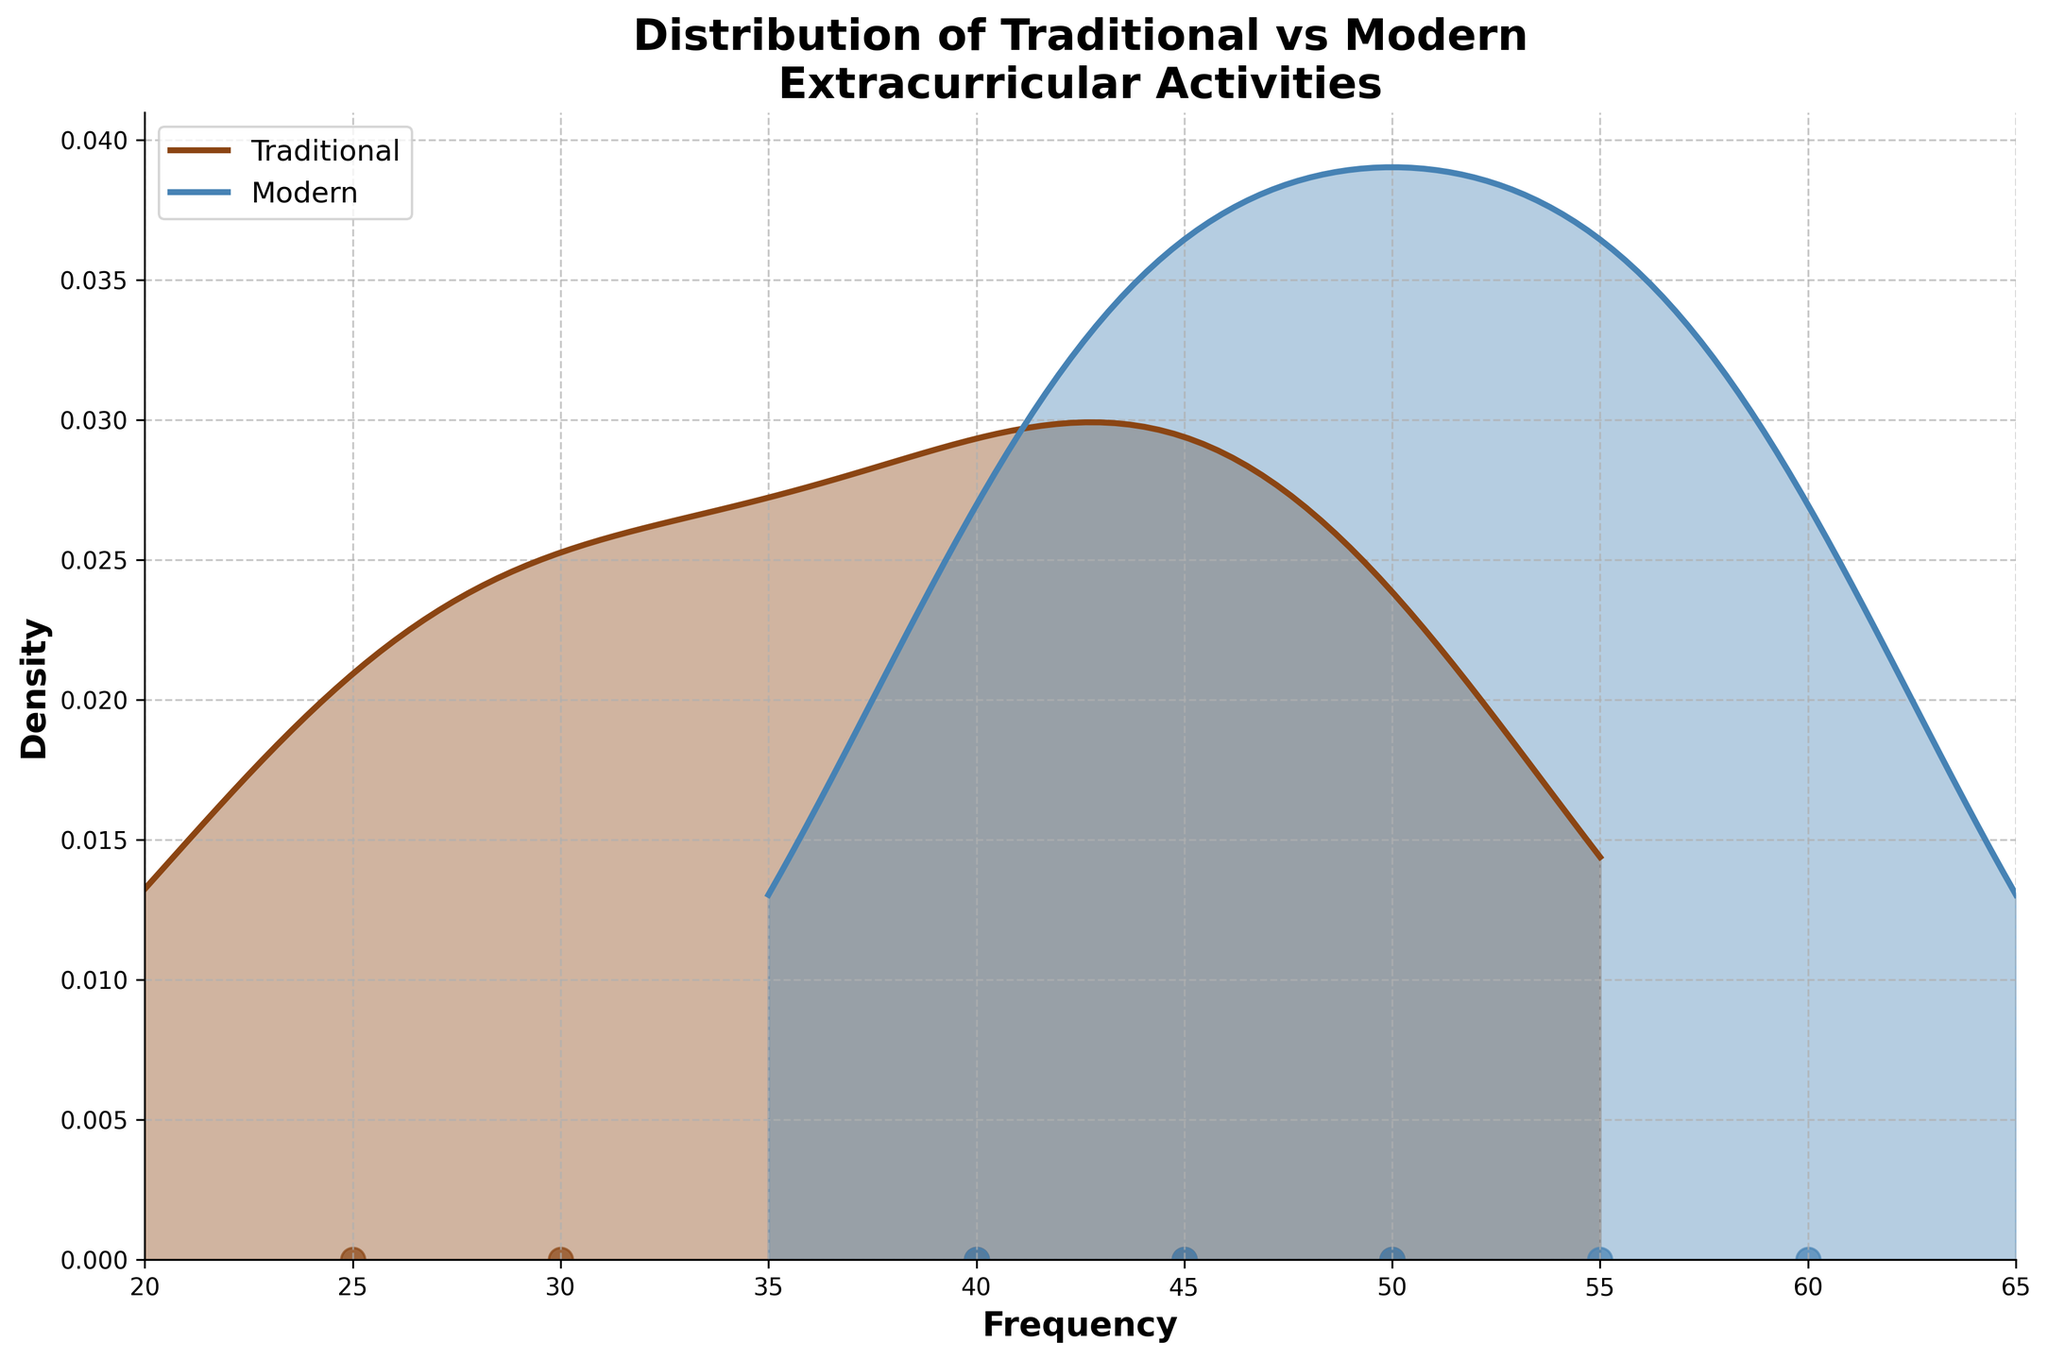What is the title of the figure? The title is located at the top of the figure. It reads "Distribution of Traditional vs Modern Extracurricular Activities".
Answer: Distribution of Traditional vs Modern Extracurricular Activities What colors represent traditional and modern activities? The colors are found by examining the legend on the top left corner of the figure. Brown represents Traditional activities, and Steel Blue represents Modern activities.
Answer: Brown for Traditional, Steel Blue for Modern What is the range of frequencies represented on the x-axis? The x-axis shows the range of frequencies. It starts at 20 and ends at 65.
Answer: 20 to 65 How many data points are there for traditional activities? There are five data points in the traditional distribution, visible as brown dots in the scatter plot.
Answer: 5 Which type of activity has the highest single frequency value? By comparing the highest points on both the traditional and modern distributions, the highest point is found at 'Robotics Club' under Modern activities with a frequency of 60.
Answer: Modern What are the two most common frequencies for modern activities? The most common frequencies for modern activities can be determined by the peaks of the steel blue density curve. The highest peaks are at 45 and 60.
Answer: 45 and 60 What is the median frequency for traditional activities? To find the median for traditional activities, we arrange the frequencies in ascending order: 25, 30, 40, 45, 50. The median is the middle value, which is 40.
Answer: 40 How does the density of traditional activities compare to modern activities at a frequency of 50? By examining the height of the density curves at frequency 50, the density for traditional activities is slightly higher than that for modern activities.
Answer: Traditional is slightly higher Are there any points where the density of modern activities is zero? Observing the density curve for modern activities, it appears to never touch zero between the range of 20 and 65 on the x-axis.
Answer: No What can be inferred about the overall popularity of traditional vs. modern activities? The overall popularity can be inferred from the heights and areas under the density curves. Modern activities have generally higher and more widespread popularity, evident from a higher peak and more extended spread.
Answer: Modern activities are generally more popular 